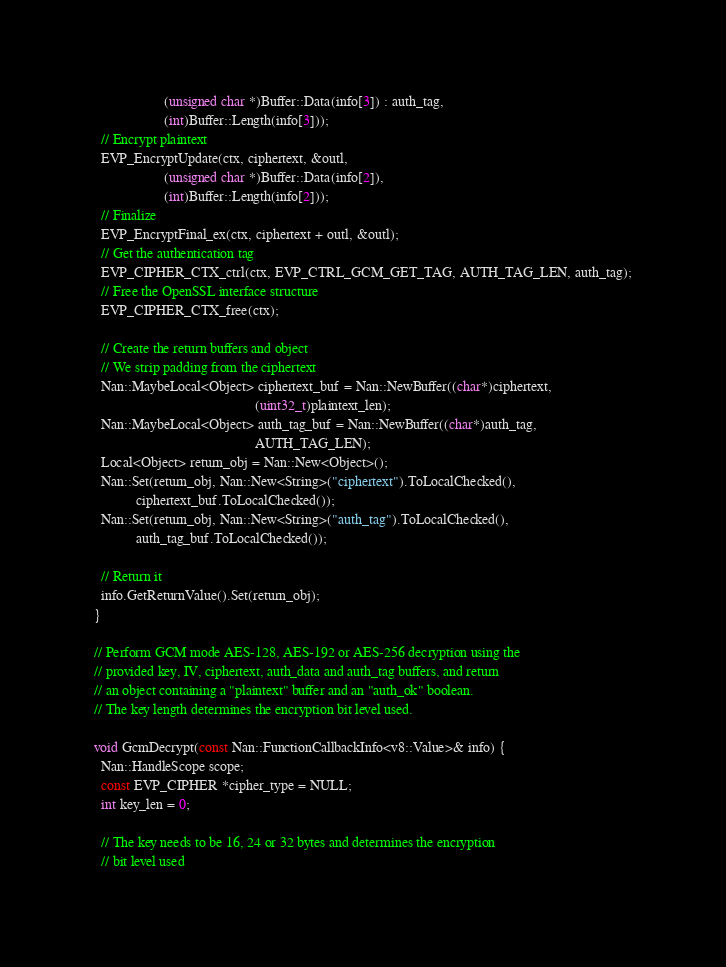Convert code to text. <code><loc_0><loc_0><loc_500><loc_500><_C++_>                    (unsigned char *)Buffer::Data(info[3]) : auth_tag,
                    (int)Buffer::Length(info[3]));
  // Encrypt plaintext
  EVP_EncryptUpdate(ctx, ciphertext, &outl,
                    (unsigned char *)Buffer::Data(info[2]),
                    (int)Buffer::Length(info[2]));
  // Finalize
  EVP_EncryptFinal_ex(ctx, ciphertext + outl, &outl);
  // Get the authentication tag
  EVP_CIPHER_CTX_ctrl(ctx, EVP_CTRL_GCM_GET_TAG, AUTH_TAG_LEN, auth_tag);
  // Free the OpenSSL interface structure
  EVP_CIPHER_CTX_free(ctx);

  // Create the return buffers and object
  // We strip padding from the ciphertext
  Nan::MaybeLocal<Object> ciphertext_buf = Nan::NewBuffer((char*)ciphertext,
                                              (uint32_t)plaintext_len);
  Nan::MaybeLocal<Object> auth_tag_buf = Nan::NewBuffer((char*)auth_tag,
                                              AUTH_TAG_LEN);
  Local<Object> return_obj = Nan::New<Object>();
  Nan::Set(return_obj, Nan::New<String>("ciphertext").ToLocalChecked(),
            ciphertext_buf.ToLocalChecked());
  Nan::Set(return_obj, Nan::New<String>("auth_tag").ToLocalChecked(),
            auth_tag_buf.ToLocalChecked());

  // Return it
  info.GetReturnValue().Set(return_obj);
}

// Perform GCM mode AES-128, AES-192 or AES-256 decryption using the
// provided key, IV, ciphertext, auth_data and auth_tag buffers, and return
// an object containing a "plaintext" buffer and an "auth_ok" boolean.
// The key length determines the encryption bit level used.

void GcmDecrypt(const Nan::FunctionCallbackInfo<v8::Value>& info) {
  Nan::HandleScope scope;
  const EVP_CIPHER *cipher_type = NULL;
  int key_len = 0;

  // The key needs to be 16, 24 or 32 bytes and determines the encryption
  // bit level used</code> 